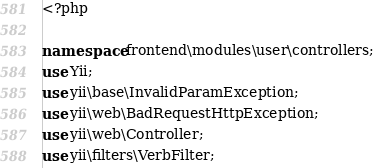<code> <loc_0><loc_0><loc_500><loc_500><_PHP_><?php

namespace frontend\modules\user\controllers;
use Yii;
use yii\base\InvalidParamException;
use yii\web\BadRequestHttpException;
use yii\web\Controller;
use yii\filters\VerbFilter;</code> 